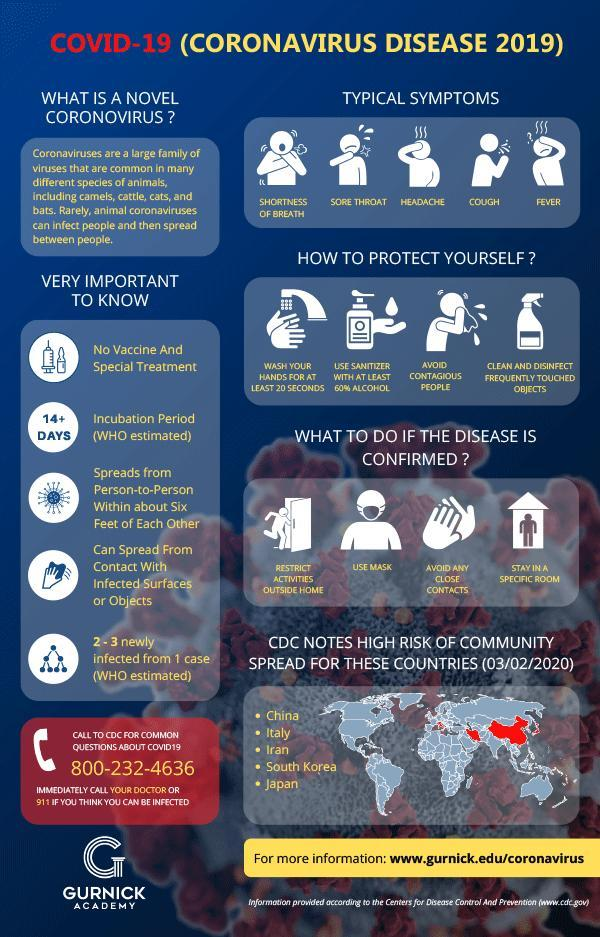What is the third point mentioned under corona preventive measures?
Answer the question with a short phrase. avoid contagious people Which indication of corona is listed second in the infographic? sore throat What is the color code given to countries in high risk category- black, white, yellow, red? red What is the protocol distance to be maintained in social distancing? six feet Which is the fifth country listed in high risk category due to corona? Japan What is the third point mentioned under what should be done if corona is confirmed? Avoid any close contacts Which is the type of corona virus which might get transfer into humans? animal coronaviruses To how many people the disease can spread from a single person? 2-3 What is the proper way to clean hands in order to prevent corona? Wash your hands for at least 20 seconds What is the fourth point mentioned under what should be done if corona is confirmed? stay in a specific room 